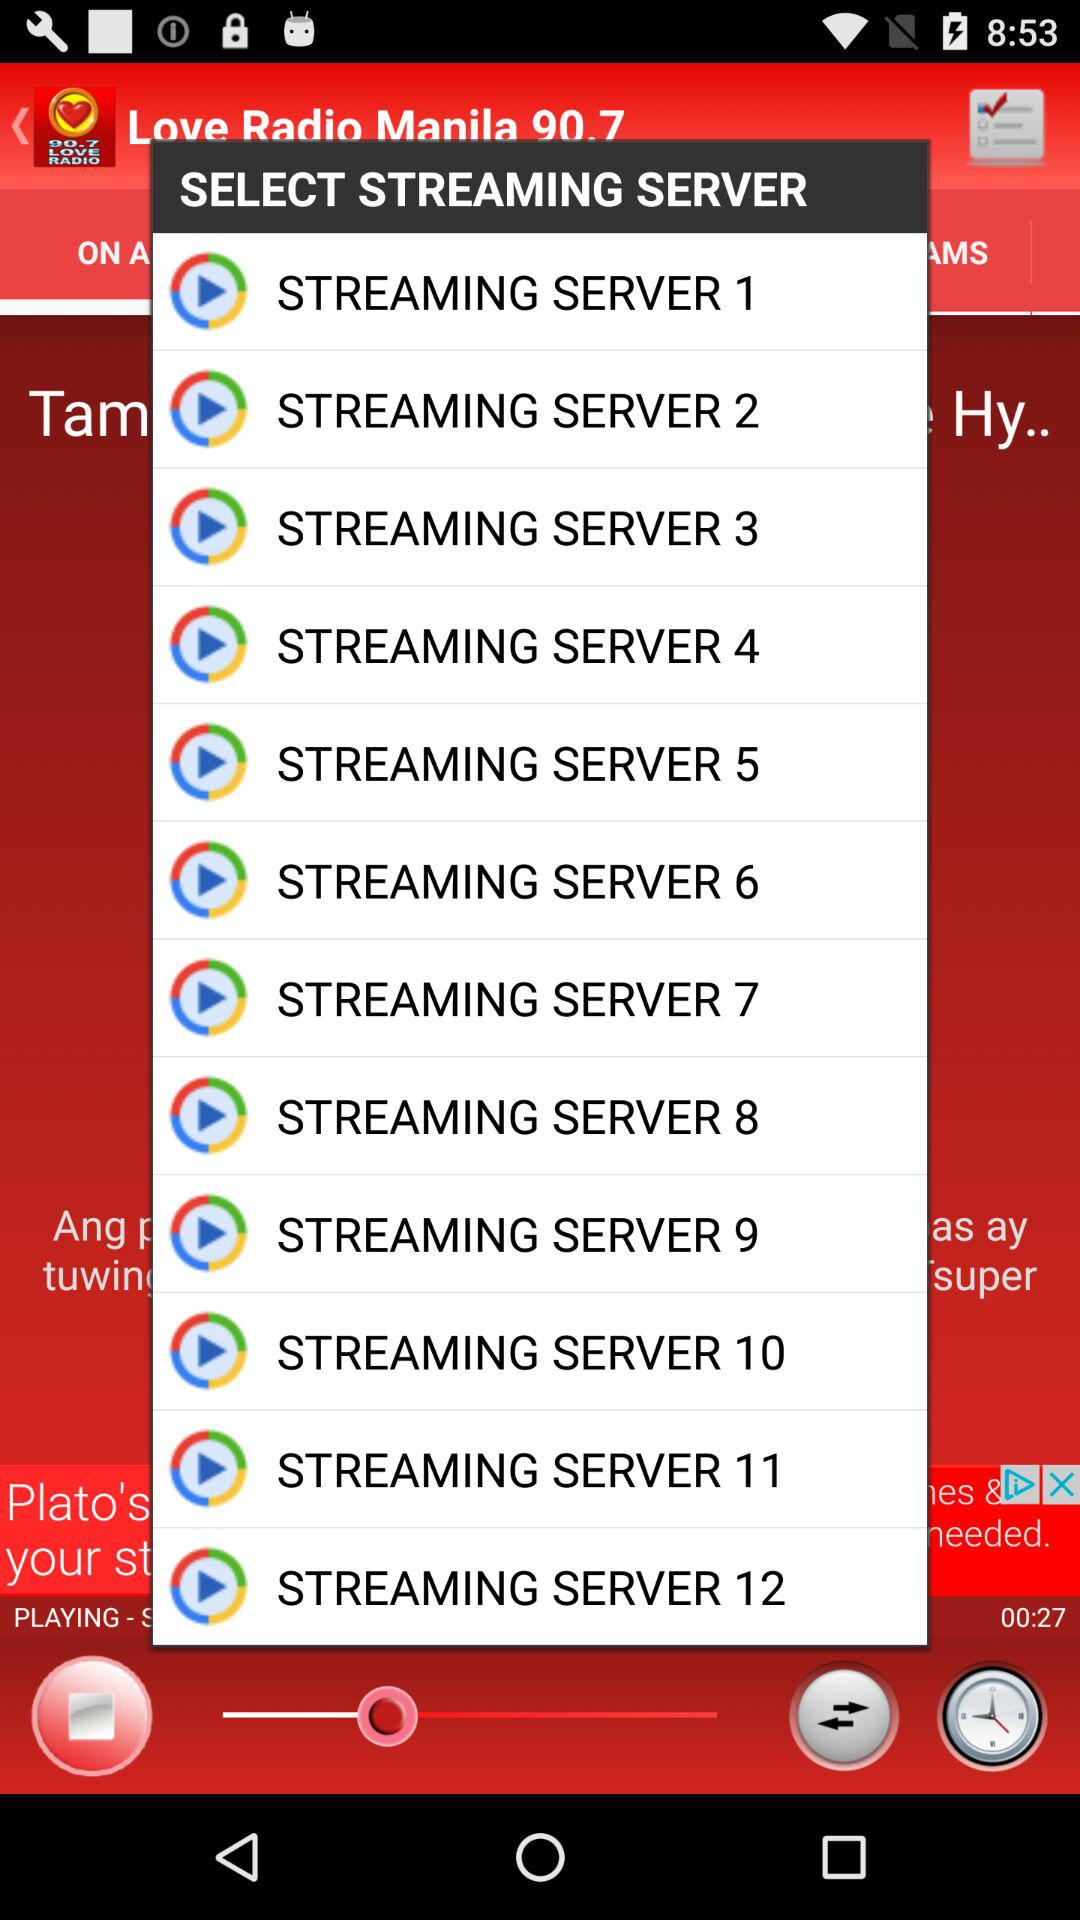How many streaming servers are there?
Answer the question using a single word or phrase. 12 